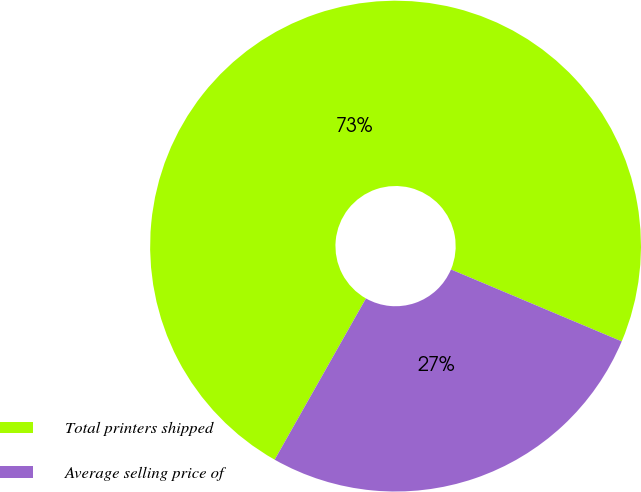<chart> <loc_0><loc_0><loc_500><loc_500><pie_chart><fcel>Total printers shipped<fcel>Average selling price of<nl><fcel>73.15%<fcel>26.85%<nl></chart> 